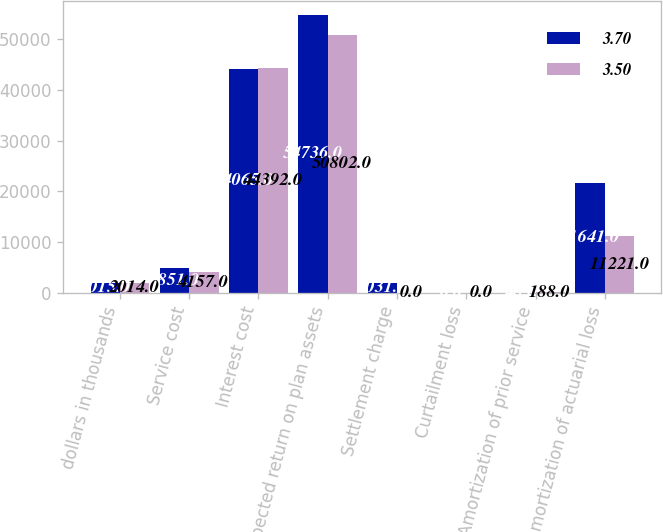Convert chart. <chart><loc_0><loc_0><loc_500><loc_500><stacked_bar_chart><ecel><fcel>dollars in thousands<fcel>Service cost<fcel>Interest cost<fcel>Expected return on plan assets<fcel>Settlement charge<fcel>Curtailment loss<fcel>Amortization of prior service<fcel>Amortization of actuarial loss<nl><fcel>3.7<fcel>2015<fcel>4851<fcel>44065<fcel>54736<fcel>2031<fcel>0<fcel>48<fcel>21641<nl><fcel>3.5<fcel>2014<fcel>4157<fcel>44392<fcel>50802<fcel>0<fcel>0<fcel>188<fcel>11221<nl></chart> 